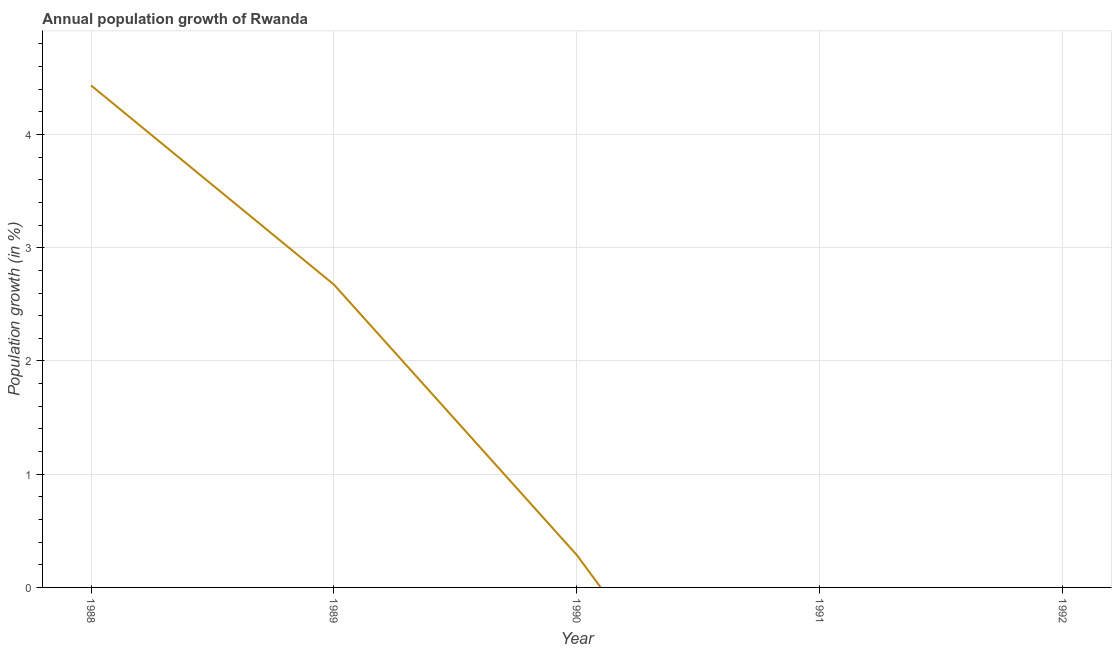Across all years, what is the maximum population growth?
Give a very brief answer. 4.43. What is the sum of the population growth?
Give a very brief answer. 7.39. What is the difference between the population growth in 1988 and 1989?
Give a very brief answer. 1.76. What is the average population growth per year?
Give a very brief answer. 1.48. What is the median population growth?
Offer a terse response. 0.28. In how many years, is the population growth greater than 1.8 %?
Offer a very short reply. 2. What is the ratio of the population growth in 1989 to that in 1990?
Give a very brief answer. 9.39. Is the difference between the population growth in 1988 and 1990 greater than the difference between any two years?
Keep it short and to the point. No. What is the difference between the highest and the second highest population growth?
Ensure brevity in your answer.  1.76. Is the sum of the population growth in 1988 and 1989 greater than the maximum population growth across all years?
Make the answer very short. Yes. What is the difference between the highest and the lowest population growth?
Your answer should be compact. 4.43. Does the population growth monotonically increase over the years?
Offer a very short reply. No. How many years are there in the graph?
Offer a terse response. 5. Does the graph contain any zero values?
Your answer should be very brief. Yes. What is the title of the graph?
Your answer should be compact. Annual population growth of Rwanda. What is the label or title of the X-axis?
Your answer should be very brief. Year. What is the label or title of the Y-axis?
Your answer should be very brief. Population growth (in %). What is the Population growth (in %) in 1988?
Give a very brief answer. 4.43. What is the Population growth (in %) in 1989?
Ensure brevity in your answer.  2.67. What is the Population growth (in %) in 1990?
Give a very brief answer. 0.28. What is the difference between the Population growth (in %) in 1988 and 1989?
Your answer should be compact. 1.76. What is the difference between the Population growth (in %) in 1988 and 1990?
Your answer should be very brief. 4.15. What is the difference between the Population growth (in %) in 1989 and 1990?
Keep it short and to the point. 2.39. What is the ratio of the Population growth (in %) in 1988 to that in 1989?
Offer a terse response. 1.66. What is the ratio of the Population growth (in %) in 1988 to that in 1990?
Your answer should be very brief. 15.57. What is the ratio of the Population growth (in %) in 1989 to that in 1990?
Offer a terse response. 9.39. 